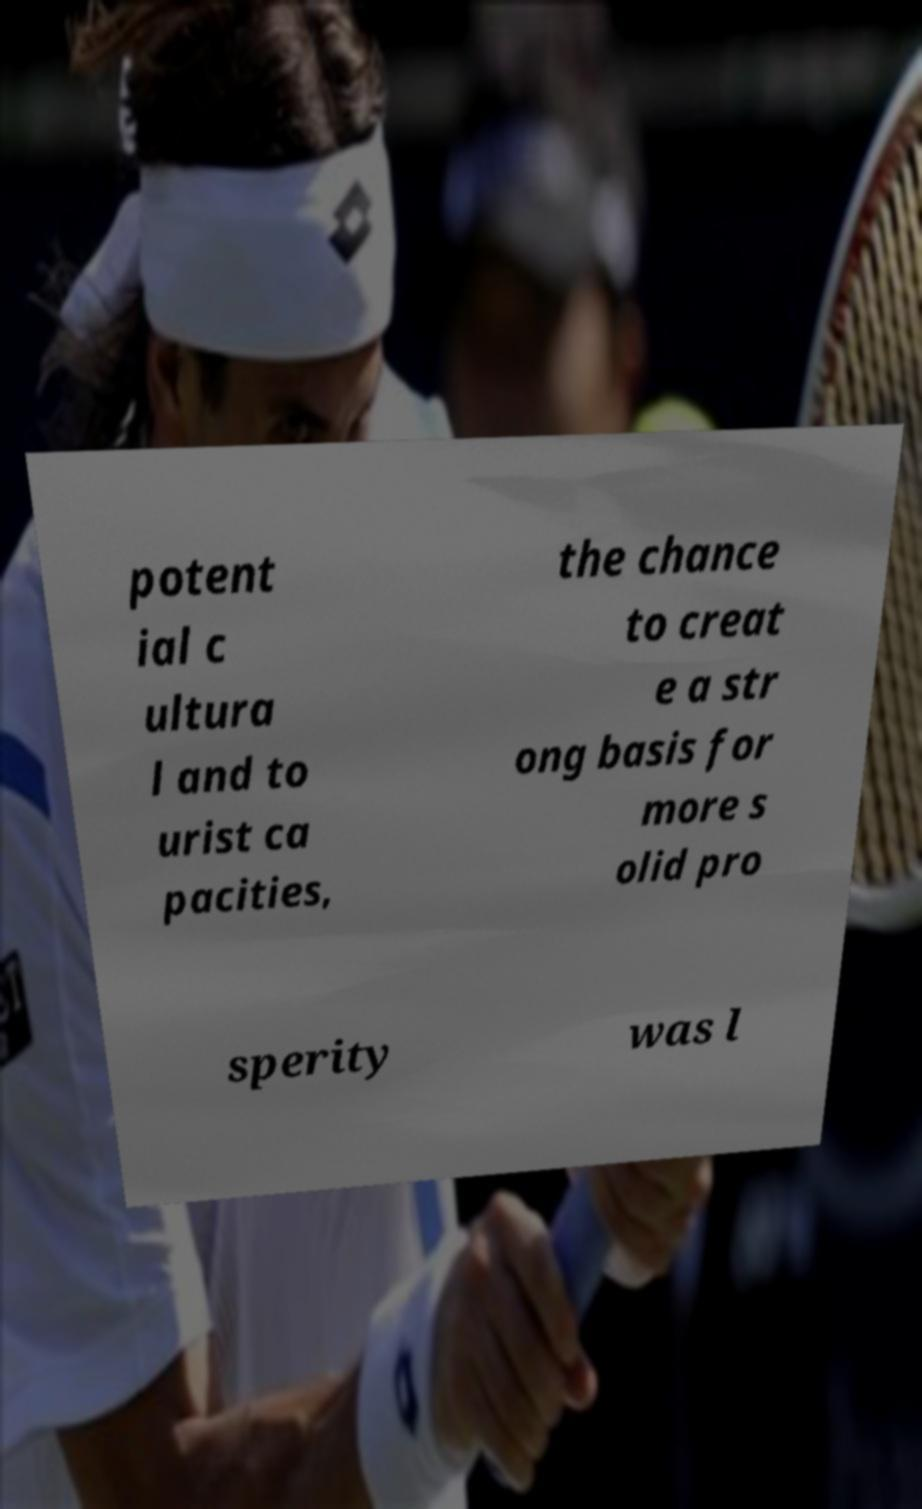I need the written content from this picture converted into text. Can you do that? potent ial c ultura l and to urist ca pacities, the chance to creat e a str ong basis for more s olid pro sperity was l 